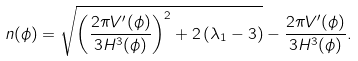Convert formula to latex. <formula><loc_0><loc_0><loc_500><loc_500>n ( \phi ) = \sqrt { \left ( \frac { 2 \pi V ^ { \prime } ( \phi ) } { 3 H ^ { 3 } ( \phi ) } \right ) ^ { 2 } + 2 \left ( \lambda _ { 1 } - 3 \right ) } - \frac { 2 \pi V ^ { \prime } ( \phi ) } { 3 H ^ { 3 } ( \phi ) } .</formula> 